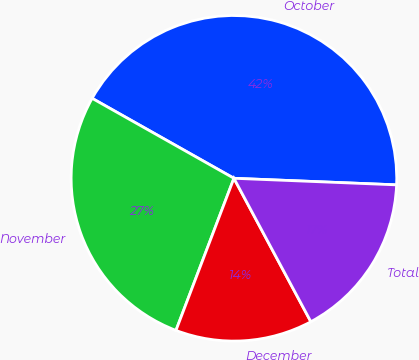<chart> <loc_0><loc_0><loc_500><loc_500><pie_chart><fcel>October<fcel>November<fcel>December<fcel>Total<nl><fcel>42.47%<fcel>27.38%<fcel>13.63%<fcel>16.52%<nl></chart> 